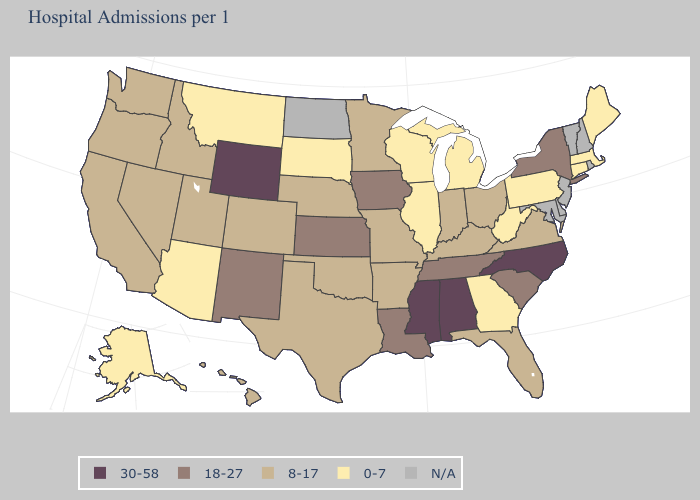Among the states that border South Dakota , which have the highest value?
Concise answer only. Wyoming. Name the states that have a value in the range 8-17?
Answer briefly. Arkansas, California, Colorado, Florida, Hawaii, Idaho, Indiana, Kentucky, Minnesota, Missouri, Nebraska, Nevada, Ohio, Oklahoma, Oregon, Texas, Utah, Virginia, Washington. Which states hav the highest value in the MidWest?
Keep it brief. Iowa, Kansas. Name the states that have a value in the range N/A?
Quick response, please. Delaware, Maryland, New Hampshire, New Jersey, North Dakota, Rhode Island, Vermont. Name the states that have a value in the range 0-7?
Answer briefly. Alaska, Arizona, Connecticut, Georgia, Illinois, Maine, Massachusetts, Michigan, Montana, Pennsylvania, South Dakota, West Virginia, Wisconsin. Name the states that have a value in the range 0-7?
Write a very short answer. Alaska, Arizona, Connecticut, Georgia, Illinois, Maine, Massachusetts, Michigan, Montana, Pennsylvania, South Dakota, West Virginia, Wisconsin. Among the states that border Kentucky , does Tennessee have the lowest value?
Give a very brief answer. No. What is the value of Virginia?
Be succinct. 8-17. What is the value of Rhode Island?
Give a very brief answer. N/A. What is the highest value in the West ?
Give a very brief answer. 30-58. Name the states that have a value in the range 0-7?
Quick response, please. Alaska, Arizona, Connecticut, Georgia, Illinois, Maine, Massachusetts, Michigan, Montana, Pennsylvania, South Dakota, West Virginia, Wisconsin. What is the highest value in states that border Georgia?
Quick response, please. 30-58. Name the states that have a value in the range 18-27?
Short answer required. Iowa, Kansas, Louisiana, New Mexico, New York, South Carolina, Tennessee. Does Wisconsin have the lowest value in the MidWest?
Write a very short answer. Yes. Is the legend a continuous bar?
Quick response, please. No. 